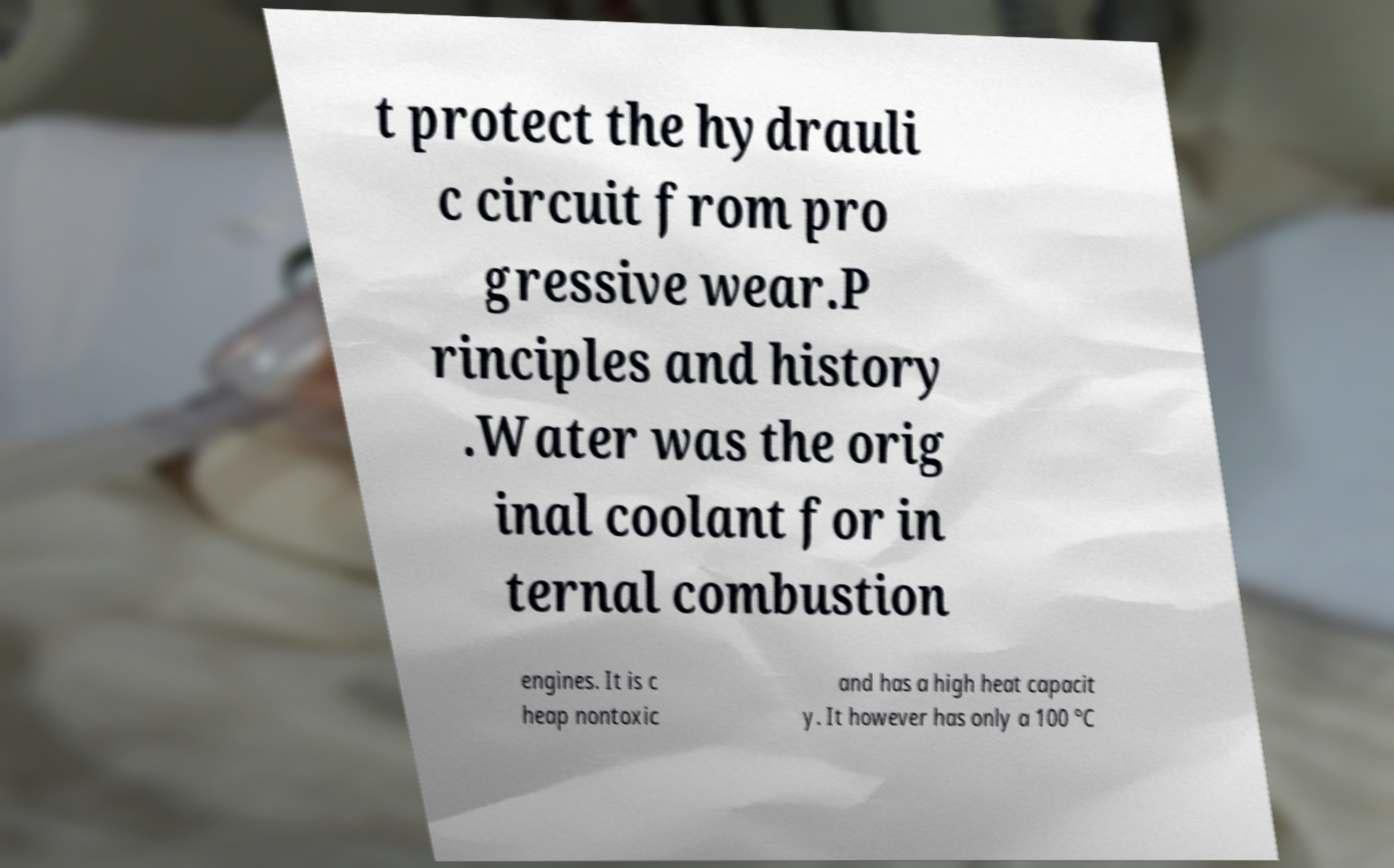Please identify and transcribe the text found in this image. t protect the hydrauli c circuit from pro gressive wear.P rinciples and history .Water was the orig inal coolant for in ternal combustion engines. It is c heap nontoxic and has a high heat capacit y. It however has only a 100 °C 